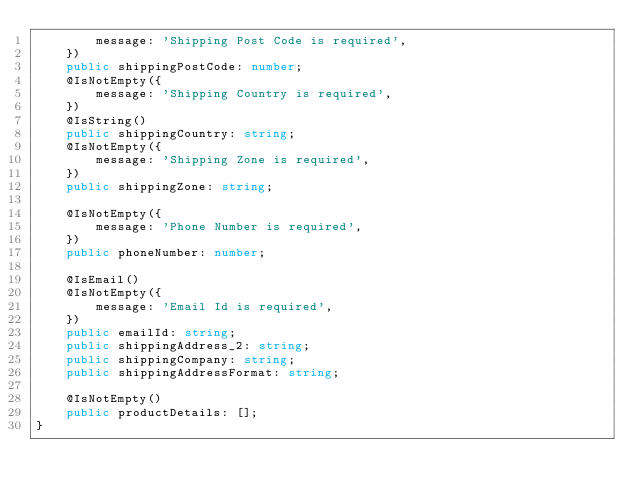Convert code to text. <code><loc_0><loc_0><loc_500><loc_500><_TypeScript_>        message: 'Shipping Post Code is required',
    })
    public shippingPostCode: number;
    @IsNotEmpty({
        message: 'Shipping Country is required',
    })
    @IsString()
    public shippingCountry: string;
    @IsNotEmpty({
        message: 'Shipping Zone is required',
    })
    public shippingZone: string;

    @IsNotEmpty({
        message: 'Phone Number is required',
    })
    public phoneNumber: number;

    @IsEmail()
    @IsNotEmpty({
        message: 'Email Id is required',
    })
    public emailId: string;
    public shippingAddress_2: string;
    public shippingCompany: string;
    public shippingAddressFormat: string;

    @IsNotEmpty()
    public productDetails: [];
}
</code> 